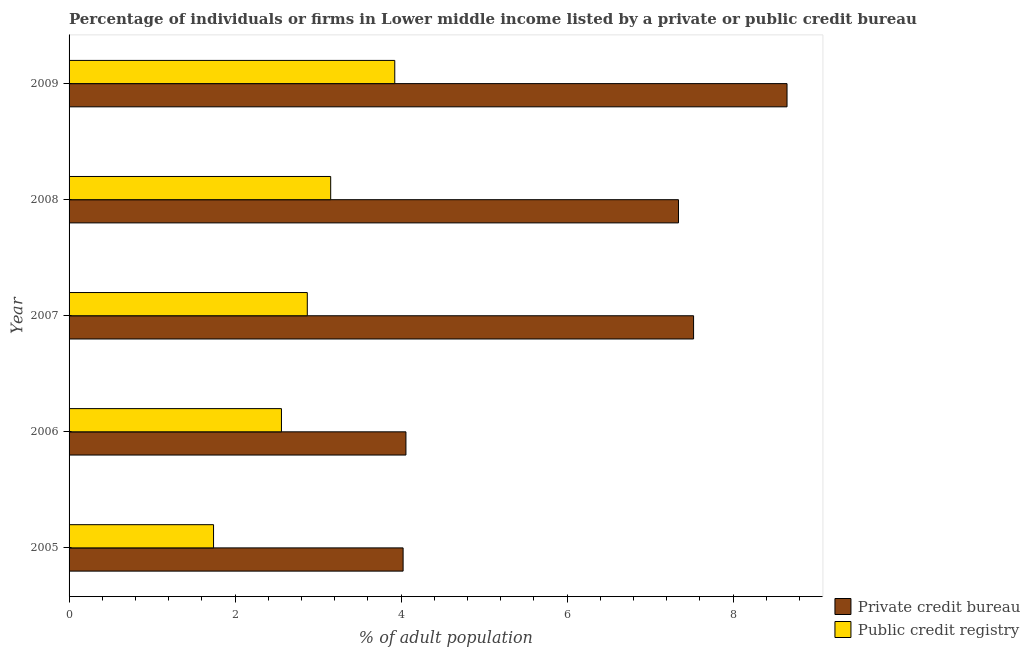Are the number of bars per tick equal to the number of legend labels?
Give a very brief answer. Yes. Are the number of bars on each tick of the Y-axis equal?
Your answer should be compact. Yes. How many bars are there on the 2nd tick from the top?
Make the answer very short. 2. How many bars are there on the 3rd tick from the bottom?
Your answer should be compact. 2. What is the label of the 5th group of bars from the top?
Offer a terse response. 2005. What is the percentage of firms listed by private credit bureau in 2006?
Ensure brevity in your answer.  4.06. Across all years, what is the maximum percentage of firms listed by private credit bureau?
Offer a very short reply. 8.65. Across all years, what is the minimum percentage of firms listed by public credit bureau?
Offer a very short reply. 1.74. In which year was the percentage of firms listed by public credit bureau minimum?
Offer a terse response. 2005. What is the total percentage of firms listed by private credit bureau in the graph?
Ensure brevity in your answer.  31.6. What is the difference between the percentage of firms listed by private credit bureau in 2006 and that in 2008?
Keep it short and to the point. -3.28. What is the difference between the percentage of firms listed by private credit bureau in 2009 and the percentage of firms listed by public credit bureau in 2005?
Provide a succinct answer. 6.91. What is the average percentage of firms listed by public credit bureau per year?
Ensure brevity in your answer.  2.85. In the year 2007, what is the difference between the percentage of firms listed by public credit bureau and percentage of firms listed by private credit bureau?
Offer a very short reply. -4.66. In how many years, is the percentage of firms listed by public credit bureau greater than 7.6 %?
Offer a terse response. 0. What is the ratio of the percentage of firms listed by public credit bureau in 2006 to that in 2007?
Make the answer very short. 0.89. What is the difference between the highest and the second highest percentage of firms listed by public credit bureau?
Ensure brevity in your answer.  0.77. What is the difference between the highest and the lowest percentage of firms listed by public credit bureau?
Make the answer very short. 2.18. What does the 1st bar from the top in 2009 represents?
Offer a terse response. Public credit registry. What does the 1st bar from the bottom in 2007 represents?
Offer a very short reply. Private credit bureau. How many bars are there?
Your answer should be compact. 10. What is the difference between two consecutive major ticks on the X-axis?
Provide a succinct answer. 2. Does the graph contain grids?
Provide a succinct answer. No. Where does the legend appear in the graph?
Your answer should be very brief. Bottom right. How many legend labels are there?
Keep it short and to the point. 2. What is the title of the graph?
Your answer should be very brief. Percentage of individuals or firms in Lower middle income listed by a private or public credit bureau. What is the label or title of the X-axis?
Provide a short and direct response. % of adult population. What is the label or title of the Y-axis?
Offer a terse response. Year. What is the % of adult population in Private credit bureau in 2005?
Offer a terse response. 4.03. What is the % of adult population in Public credit registry in 2005?
Keep it short and to the point. 1.74. What is the % of adult population in Private credit bureau in 2006?
Provide a succinct answer. 4.06. What is the % of adult population in Public credit registry in 2006?
Your response must be concise. 2.56. What is the % of adult population in Private credit bureau in 2007?
Keep it short and to the point. 7.53. What is the % of adult population in Public credit registry in 2007?
Offer a very short reply. 2.87. What is the % of adult population of Private credit bureau in 2008?
Your answer should be very brief. 7.34. What is the % of adult population of Public credit registry in 2008?
Provide a short and direct response. 3.15. What is the % of adult population in Private credit bureau in 2009?
Keep it short and to the point. 8.65. What is the % of adult population of Public credit registry in 2009?
Ensure brevity in your answer.  3.92. Across all years, what is the maximum % of adult population of Private credit bureau?
Keep it short and to the point. 8.65. Across all years, what is the maximum % of adult population in Public credit registry?
Your answer should be compact. 3.92. Across all years, what is the minimum % of adult population in Private credit bureau?
Your answer should be compact. 4.03. Across all years, what is the minimum % of adult population of Public credit registry?
Your answer should be compact. 1.74. What is the total % of adult population in Private credit bureau in the graph?
Your answer should be very brief. 31.6. What is the total % of adult population in Public credit registry in the graph?
Your answer should be very brief. 14.25. What is the difference between the % of adult population in Private credit bureau in 2005 and that in 2006?
Ensure brevity in your answer.  -0.03. What is the difference between the % of adult population in Public credit registry in 2005 and that in 2006?
Your answer should be very brief. -0.82. What is the difference between the % of adult population of Public credit registry in 2005 and that in 2007?
Offer a very short reply. -1.13. What is the difference between the % of adult population of Private credit bureau in 2005 and that in 2008?
Your answer should be compact. -3.32. What is the difference between the % of adult population in Public credit registry in 2005 and that in 2008?
Keep it short and to the point. -1.41. What is the difference between the % of adult population in Private credit bureau in 2005 and that in 2009?
Your answer should be compact. -4.63. What is the difference between the % of adult population in Public credit registry in 2005 and that in 2009?
Offer a terse response. -2.18. What is the difference between the % of adult population in Private credit bureau in 2006 and that in 2007?
Ensure brevity in your answer.  -3.47. What is the difference between the % of adult population of Public credit registry in 2006 and that in 2007?
Offer a terse response. -0.31. What is the difference between the % of adult population in Private credit bureau in 2006 and that in 2008?
Your response must be concise. -3.28. What is the difference between the % of adult population in Public credit registry in 2006 and that in 2008?
Your answer should be compact. -0.59. What is the difference between the % of adult population of Private credit bureau in 2006 and that in 2009?
Your answer should be compact. -4.59. What is the difference between the % of adult population of Public credit registry in 2006 and that in 2009?
Your answer should be very brief. -1.37. What is the difference between the % of adult population in Private credit bureau in 2007 and that in 2008?
Provide a succinct answer. 0.18. What is the difference between the % of adult population in Public credit registry in 2007 and that in 2008?
Ensure brevity in your answer.  -0.28. What is the difference between the % of adult population of Private credit bureau in 2007 and that in 2009?
Offer a terse response. -1.13. What is the difference between the % of adult population of Public credit registry in 2007 and that in 2009?
Offer a terse response. -1.05. What is the difference between the % of adult population in Private credit bureau in 2008 and that in 2009?
Provide a short and direct response. -1.31. What is the difference between the % of adult population of Public credit registry in 2008 and that in 2009?
Your response must be concise. -0.77. What is the difference between the % of adult population of Private credit bureau in 2005 and the % of adult population of Public credit registry in 2006?
Give a very brief answer. 1.47. What is the difference between the % of adult population in Private credit bureau in 2005 and the % of adult population in Public credit registry in 2007?
Provide a short and direct response. 1.15. What is the difference between the % of adult population in Private credit bureau in 2005 and the % of adult population in Public credit registry in 2008?
Offer a very short reply. 0.87. What is the difference between the % of adult population in Private credit bureau in 2005 and the % of adult population in Public credit registry in 2009?
Provide a succinct answer. 0.1. What is the difference between the % of adult population in Private credit bureau in 2006 and the % of adult population in Public credit registry in 2007?
Offer a very short reply. 1.19. What is the difference between the % of adult population in Private credit bureau in 2006 and the % of adult population in Public credit registry in 2008?
Offer a terse response. 0.91. What is the difference between the % of adult population in Private credit bureau in 2006 and the % of adult population in Public credit registry in 2009?
Your answer should be very brief. 0.13. What is the difference between the % of adult population of Private credit bureau in 2007 and the % of adult population of Public credit registry in 2008?
Provide a short and direct response. 4.37. What is the difference between the % of adult population of Private credit bureau in 2007 and the % of adult population of Public credit registry in 2009?
Keep it short and to the point. 3.6. What is the difference between the % of adult population of Private credit bureau in 2008 and the % of adult population of Public credit registry in 2009?
Keep it short and to the point. 3.42. What is the average % of adult population of Private credit bureau per year?
Make the answer very short. 6.32. What is the average % of adult population in Public credit registry per year?
Your response must be concise. 2.85. In the year 2005, what is the difference between the % of adult population in Private credit bureau and % of adult population in Public credit registry?
Your answer should be very brief. 2.28. In the year 2007, what is the difference between the % of adult population of Private credit bureau and % of adult population of Public credit registry?
Provide a short and direct response. 4.65. In the year 2008, what is the difference between the % of adult population in Private credit bureau and % of adult population in Public credit registry?
Offer a terse response. 4.19. In the year 2009, what is the difference between the % of adult population of Private credit bureau and % of adult population of Public credit registry?
Provide a succinct answer. 4.73. What is the ratio of the % of adult population in Private credit bureau in 2005 to that in 2006?
Offer a very short reply. 0.99. What is the ratio of the % of adult population of Public credit registry in 2005 to that in 2006?
Provide a short and direct response. 0.68. What is the ratio of the % of adult population in Private credit bureau in 2005 to that in 2007?
Offer a very short reply. 0.53. What is the ratio of the % of adult population in Public credit registry in 2005 to that in 2007?
Ensure brevity in your answer.  0.61. What is the ratio of the % of adult population in Private credit bureau in 2005 to that in 2008?
Your answer should be very brief. 0.55. What is the ratio of the % of adult population in Public credit registry in 2005 to that in 2008?
Your response must be concise. 0.55. What is the ratio of the % of adult population of Private credit bureau in 2005 to that in 2009?
Your response must be concise. 0.47. What is the ratio of the % of adult population in Public credit registry in 2005 to that in 2009?
Provide a succinct answer. 0.44. What is the ratio of the % of adult population of Private credit bureau in 2006 to that in 2007?
Keep it short and to the point. 0.54. What is the ratio of the % of adult population in Public credit registry in 2006 to that in 2007?
Your answer should be compact. 0.89. What is the ratio of the % of adult population in Private credit bureau in 2006 to that in 2008?
Give a very brief answer. 0.55. What is the ratio of the % of adult population of Public credit registry in 2006 to that in 2008?
Your response must be concise. 0.81. What is the ratio of the % of adult population in Private credit bureau in 2006 to that in 2009?
Your answer should be compact. 0.47. What is the ratio of the % of adult population of Public credit registry in 2006 to that in 2009?
Make the answer very short. 0.65. What is the ratio of the % of adult population in Private credit bureau in 2007 to that in 2008?
Your response must be concise. 1.02. What is the ratio of the % of adult population of Public credit registry in 2007 to that in 2008?
Give a very brief answer. 0.91. What is the ratio of the % of adult population in Private credit bureau in 2007 to that in 2009?
Make the answer very short. 0.87. What is the ratio of the % of adult population of Public credit registry in 2007 to that in 2009?
Make the answer very short. 0.73. What is the ratio of the % of adult population in Private credit bureau in 2008 to that in 2009?
Provide a short and direct response. 0.85. What is the ratio of the % of adult population in Public credit registry in 2008 to that in 2009?
Your answer should be compact. 0.8. What is the difference between the highest and the second highest % of adult population in Private credit bureau?
Your answer should be compact. 1.13. What is the difference between the highest and the second highest % of adult population of Public credit registry?
Provide a succinct answer. 0.77. What is the difference between the highest and the lowest % of adult population in Private credit bureau?
Offer a very short reply. 4.63. What is the difference between the highest and the lowest % of adult population of Public credit registry?
Keep it short and to the point. 2.18. 